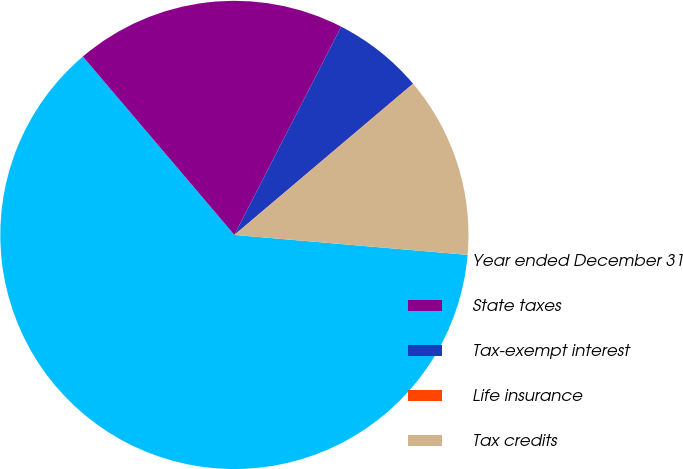<chart> <loc_0><loc_0><loc_500><loc_500><pie_chart><fcel>Year ended December 31<fcel>State taxes<fcel>Tax-exempt interest<fcel>Life insurance<fcel>Tax credits<nl><fcel>62.43%<fcel>18.75%<fcel>6.27%<fcel>0.03%<fcel>12.51%<nl></chart> 